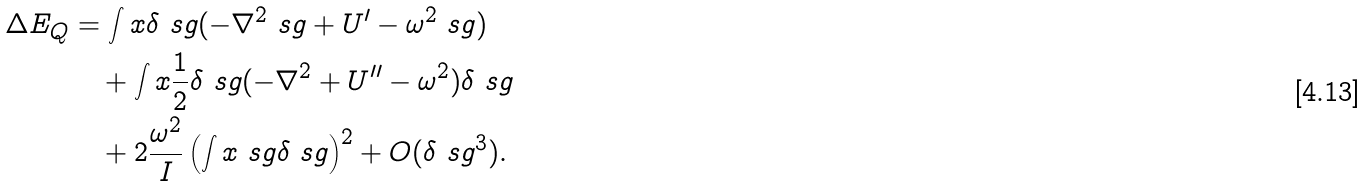Convert formula to latex. <formula><loc_0><loc_0><loc_500><loc_500>\Delta E _ { Q } & = \int x \delta \ s g ( - \nabla ^ { 2 } \ s g + U ^ { \prime } - \omega ^ { 2 } \ s g ) \\ & \quad + \int x \frac { 1 } { 2 } \delta \ s g ( - \nabla ^ { 2 } + U ^ { \prime \prime } - \omega ^ { 2 } ) \delta \ s g \\ & \quad + 2 \frac { \omega ^ { 2 } } { I } \left ( \int x \ s g \delta \ s g \right ) ^ { 2 } + O ( \delta \ s g ^ { 3 } ) .</formula> 